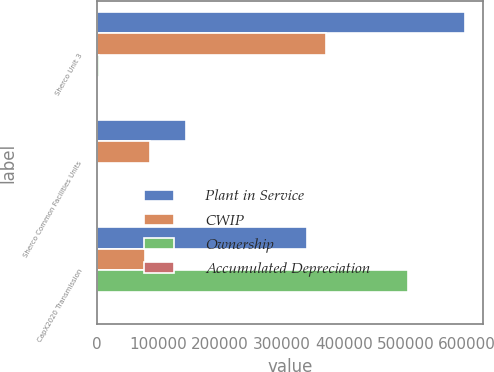Convert chart to OTSL. <chart><loc_0><loc_0><loc_500><loc_500><stacked_bar_chart><ecel><fcel>Sherco Unit 3<fcel>Sherco Common Facilities Units<fcel>CapX2020 Transmission<nl><fcel>Plant in Service<fcel>596314<fcel>145579<fcel>340333<nl><fcel>CWIP<fcel>371925<fcel>87289<fcel>77803<nl><fcel>Ownership<fcel>4533<fcel>61<fcel>503714<nl><fcel>Accumulated Depreciation<fcel>59<fcel>80<fcel>53.3<nl></chart> 